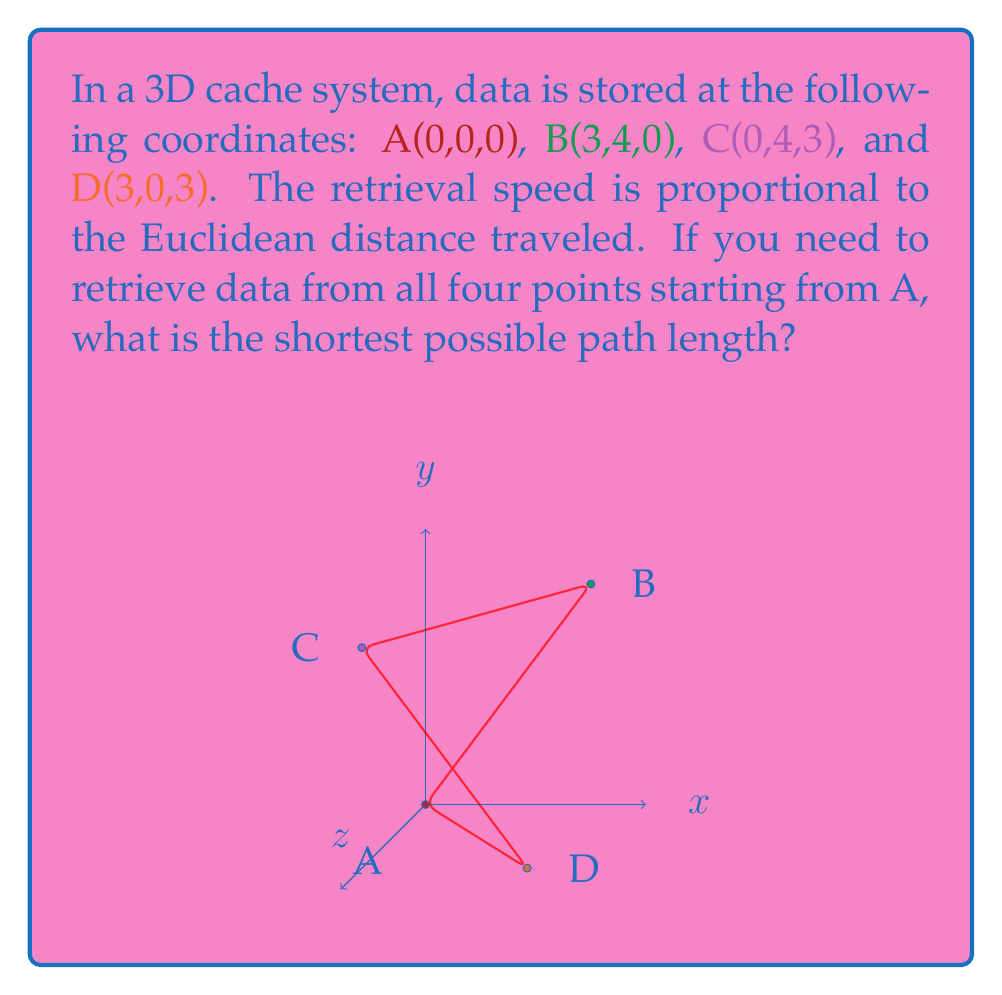Show me your answer to this math problem. To solve this problem, we need to consider all possible paths and calculate their lengths. The shortest path will be the answer. Let's approach this step-by-step:

1) First, calculate the distances between all points:
   AB = $\sqrt{3^2 + 4^2 + 0^2} = 5$
   AC = $\sqrt{0^2 + 4^2 + 3^2} = 5$
   AD = $\sqrt{3^2 + 0^2 + 3^2} = 3\sqrt{2}$
   BC = $\sqrt{3^2 + 0^2 + 3^2} = 3\sqrt{2}$
   BD = $\sqrt{0^2 + 4^2 + 3^2} = 5$
   CD = $\sqrt{3^2 + 4^2 + 0^2} = 5$

2) There are 6 possible paths starting and ending at A:
   A-B-C-D-A
   A-B-D-C-A
   A-C-B-D-A
   A-C-D-B-A
   A-D-B-C-A
   A-D-C-B-A

3) Calculate the length of each path:
   A-B-C-D-A: 5 + 3√2 + 5 + 3√2 ≈ 18.49
   A-B-D-C-A: 5 + 5 + 5 + 5 = 20
   A-C-B-D-A: 5 + 3√2 + 5 + 3√2 ≈ 18.49
   A-C-D-B-A: 5 + 5 + 5 + 5 = 20
   A-D-B-C-A: 3√2 + 5 + 3√2 + 5 ≈ 18.49
   A-D-C-B-A: 3√2 + 5 + 3√2 + 5 ≈ 18.49

4) The shortest paths are A-B-C-D-A, A-C-B-D-A, A-D-B-C-A, and A-D-C-B-A, all with a length of $10 + 6\sqrt{2}$.

5) To express this in simplest form:
   $10 + 6\sqrt{2} = 10 + 6 \cdot 1.4142... \approx 18.49$
Answer: $10 + 6\sqrt{2}$ 